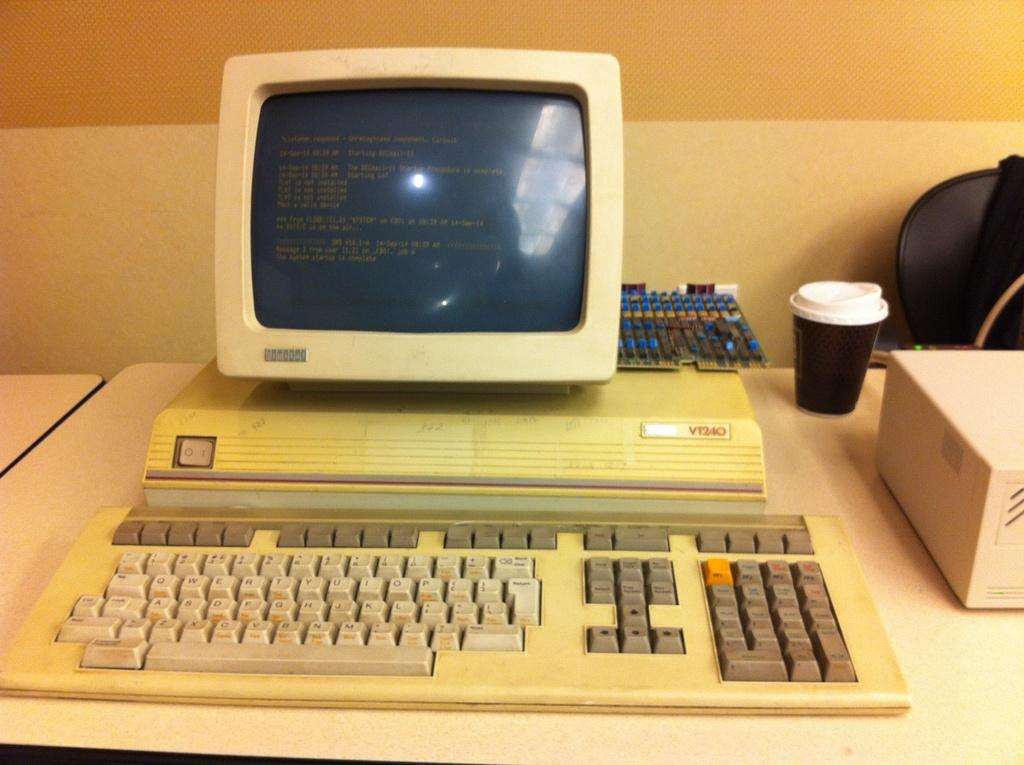<image>
Describe the image concisely. A very old VT240 screen and keyboard sits on a desk. 